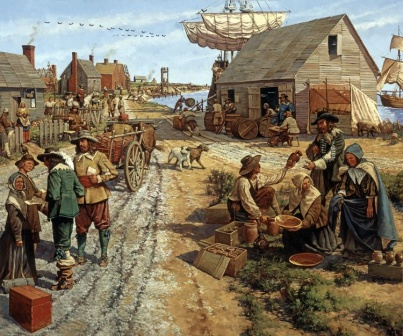Based on the image, describe a short scenario that highlights the importance of the harbor to the village. In the early hours of dawn, the village comes alive as the large merchant ship docks at the harbor. Villagers gather along the shoreline, eager to receive the latest goods from distant lands. The harbor is vital not only for trade but for the village's survival and prosperity. Barrels of spices, crates of fabric, and bundles of exotic fruits are carefully unloaded from the ship. Merchants and villagers exchange news and stories from across the sea, reinforcing bonds and opening new opportunities for trade. The arrival of the ship marks a significant event, bringing with it economic benefits and a sense of connection to the broader world. 